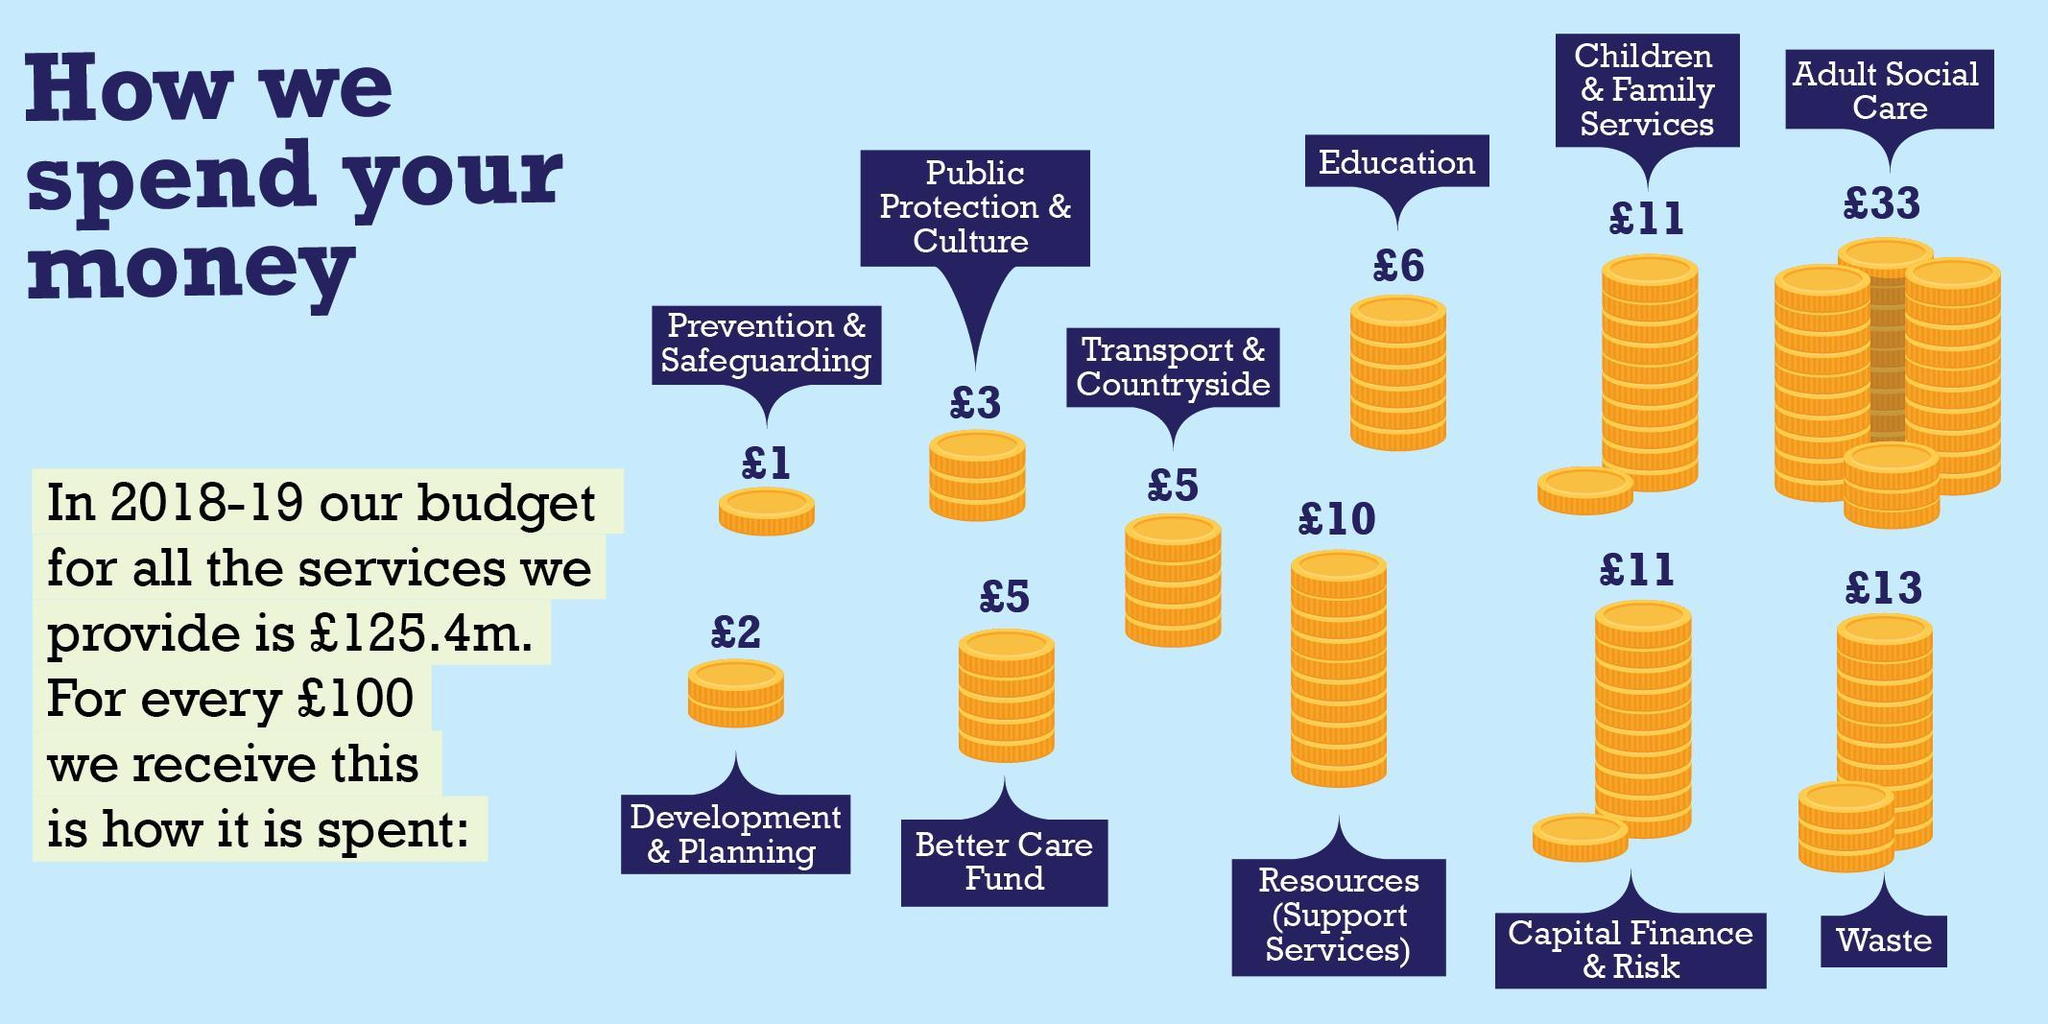What was the total spend in pounds on Adult social care and waste for every 100 spend
Answer the question with a short phrase. 46 If we received 1000 pounds, what was the amount spent on education in pounds 60 How many categories has the spend been distributed to 11 Better Care Fund spend is same as which other spend Transport & countryside How much more is the spend in pounds for Adult social care when compared to spend on waste 20 Which is the second highest spend Waste 